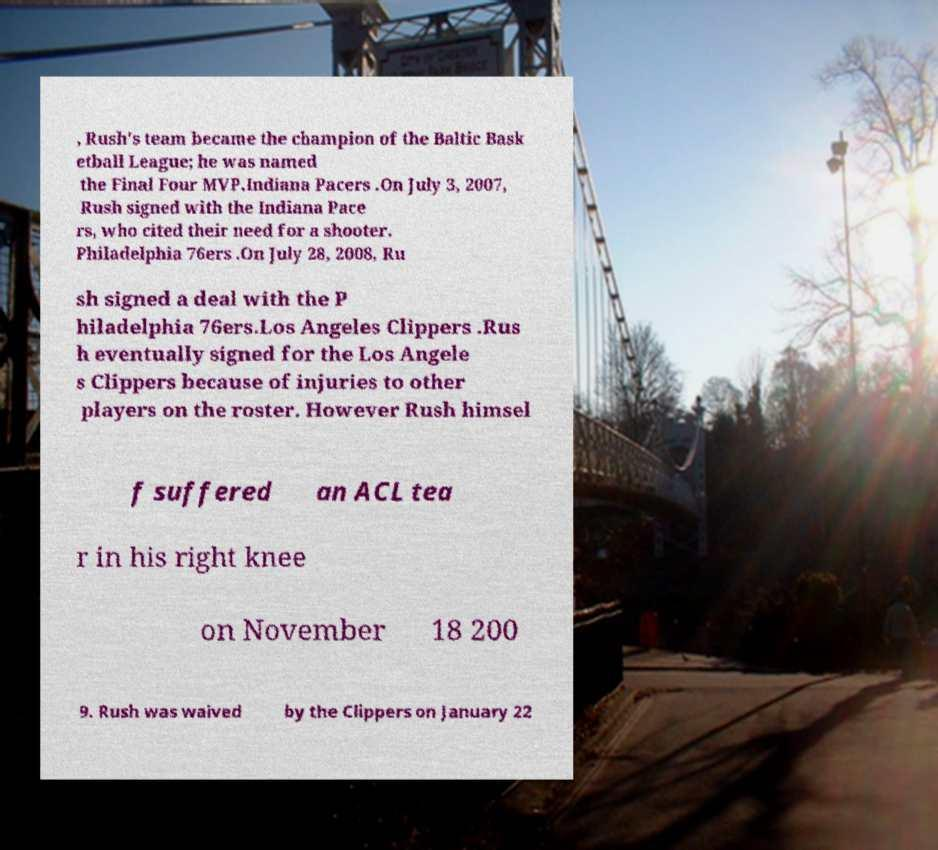Can you accurately transcribe the text from the provided image for me? , Rush's team became the champion of the Baltic Bask etball League; he was named the Final Four MVP.Indiana Pacers .On July 3, 2007, Rush signed with the Indiana Pace rs, who cited their need for a shooter. Philadelphia 76ers .On July 28, 2008, Ru sh signed a deal with the P hiladelphia 76ers.Los Angeles Clippers .Rus h eventually signed for the Los Angele s Clippers because of injuries to other players on the roster. However Rush himsel f suffered an ACL tea r in his right knee on November 18 200 9. Rush was waived by the Clippers on January 22 